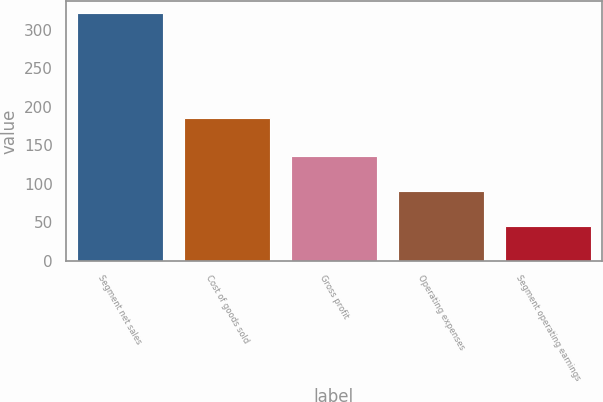<chart> <loc_0><loc_0><loc_500><loc_500><bar_chart><fcel>Segment net sales<fcel>Cost of goods sold<fcel>Gross profit<fcel>Operating expenses<fcel>Segment operating earnings<nl><fcel>321.6<fcel>185.8<fcel>135.8<fcel>90.2<fcel>45.6<nl></chart> 